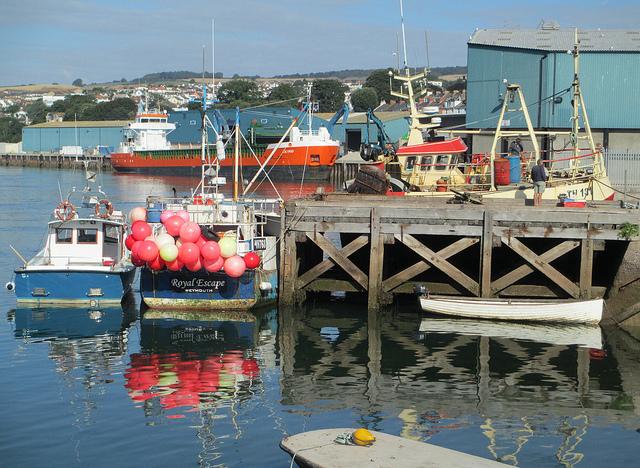What color are the buoys on the boat?
Write a very short answer. Red. Are the boats all the same type?
Write a very short answer. No. How many boats are there?
Concise answer only. 4. What is the purpose of the red ball in the middle of the canal?
Answer briefly. Balloons. 